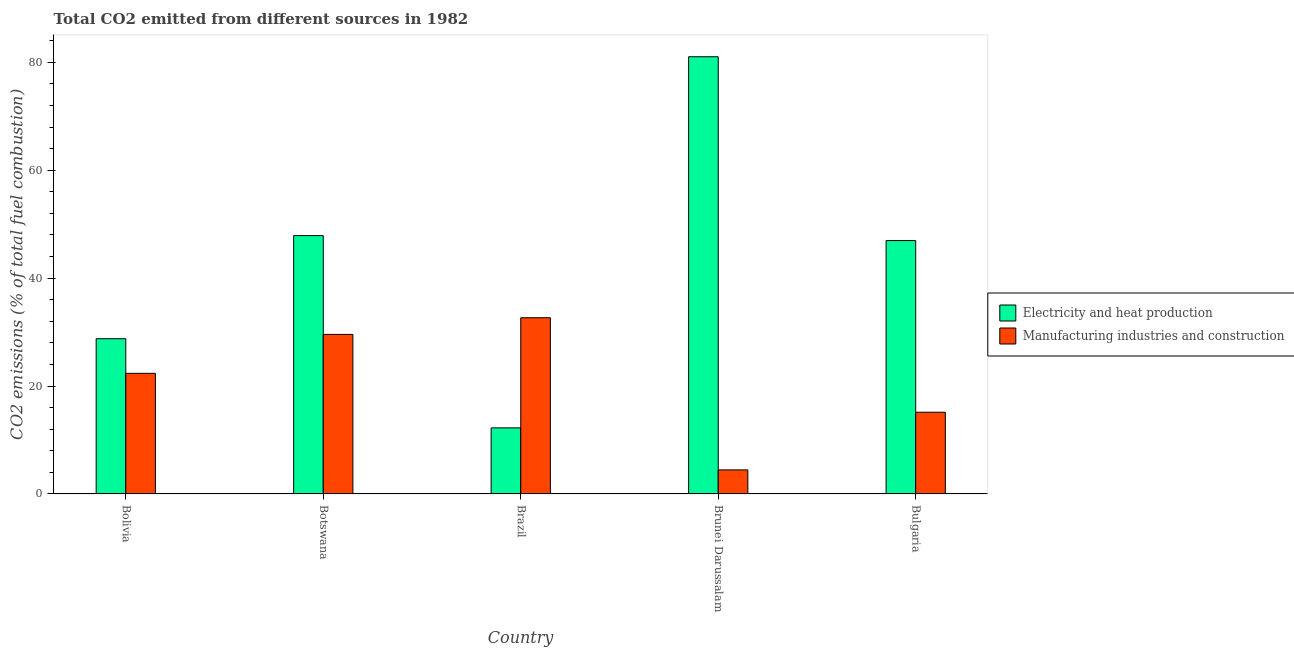How many different coloured bars are there?
Offer a very short reply. 2. How many groups of bars are there?
Your answer should be very brief. 5. Are the number of bars per tick equal to the number of legend labels?
Give a very brief answer. Yes. Are the number of bars on each tick of the X-axis equal?
Offer a terse response. Yes. How many bars are there on the 3rd tick from the left?
Offer a very short reply. 2. What is the label of the 5th group of bars from the left?
Provide a succinct answer. Bulgaria. In how many cases, is the number of bars for a given country not equal to the number of legend labels?
Keep it short and to the point. 0. What is the co2 emissions due to manufacturing industries in Bolivia?
Offer a terse response. 22.36. Across all countries, what is the maximum co2 emissions due to electricity and heat production?
Make the answer very short. 81.04. Across all countries, what is the minimum co2 emissions due to manufacturing industries?
Your response must be concise. 4.46. In which country was the co2 emissions due to electricity and heat production maximum?
Ensure brevity in your answer.  Brunei Darussalam. In which country was the co2 emissions due to manufacturing industries minimum?
Provide a short and direct response. Brunei Darussalam. What is the total co2 emissions due to electricity and heat production in the graph?
Give a very brief answer. 216.92. What is the difference between the co2 emissions due to manufacturing industries in Botswana and that in Bulgaria?
Provide a succinct answer. 14.43. What is the difference between the co2 emissions due to electricity and heat production in Brunei Darussalam and the co2 emissions due to manufacturing industries in Bulgaria?
Your response must be concise. 65.89. What is the average co2 emissions due to manufacturing industries per country?
Give a very brief answer. 20.84. What is the difference between the co2 emissions due to electricity and heat production and co2 emissions due to manufacturing industries in Bolivia?
Ensure brevity in your answer.  6.42. What is the ratio of the co2 emissions due to manufacturing industries in Botswana to that in Brunei Darussalam?
Keep it short and to the point. 6.63. Is the difference between the co2 emissions due to electricity and heat production in Bolivia and Brunei Darussalam greater than the difference between the co2 emissions due to manufacturing industries in Bolivia and Brunei Darussalam?
Your answer should be very brief. No. What is the difference between the highest and the second highest co2 emissions due to manufacturing industries?
Your answer should be compact. 3.09. What is the difference between the highest and the lowest co2 emissions due to manufacturing industries?
Offer a very short reply. 28.2. In how many countries, is the co2 emissions due to manufacturing industries greater than the average co2 emissions due to manufacturing industries taken over all countries?
Give a very brief answer. 3. Is the sum of the co2 emissions due to electricity and heat production in Botswana and Bulgaria greater than the maximum co2 emissions due to manufacturing industries across all countries?
Provide a succinct answer. Yes. What does the 1st bar from the left in Brunei Darussalam represents?
Your answer should be compact. Electricity and heat production. What does the 1st bar from the right in Bolivia represents?
Ensure brevity in your answer.  Manufacturing industries and construction. How many countries are there in the graph?
Provide a succinct answer. 5. What is the difference between two consecutive major ticks on the Y-axis?
Ensure brevity in your answer.  20. Are the values on the major ticks of Y-axis written in scientific E-notation?
Your answer should be very brief. No. How are the legend labels stacked?
Offer a terse response. Vertical. What is the title of the graph?
Keep it short and to the point. Total CO2 emitted from different sources in 1982. What is the label or title of the Y-axis?
Your response must be concise. CO2 emissions (% of total fuel combustion). What is the CO2 emissions (% of total fuel combustion) of Electricity and heat production in Bolivia?
Make the answer very short. 28.78. What is the CO2 emissions (% of total fuel combustion) of Manufacturing industries and construction in Bolivia?
Provide a short and direct response. 22.36. What is the CO2 emissions (% of total fuel combustion) of Electricity and heat production in Botswana?
Ensure brevity in your answer.  47.89. What is the CO2 emissions (% of total fuel combustion) of Manufacturing industries and construction in Botswana?
Your answer should be very brief. 29.58. What is the CO2 emissions (% of total fuel combustion) of Electricity and heat production in Brazil?
Offer a terse response. 12.25. What is the CO2 emissions (% of total fuel combustion) in Manufacturing industries and construction in Brazil?
Provide a succinct answer. 32.67. What is the CO2 emissions (% of total fuel combustion) of Electricity and heat production in Brunei Darussalam?
Your answer should be compact. 81.04. What is the CO2 emissions (% of total fuel combustion) in Manufacturing industries and construction in Brunei Darussalam?
Offer a very short reply. 4.46. What is the CO2 emissions (% of total fuel combustion) in Electricity and heat production in Bulgaria?
Keep it short and to the point. 46.97. What is the CO2 emissions (% of total fuel combustion) of Manufacturing industries and construction in Bulgaria?
Give a very brief answer. 15.15. Across all countries, what is the maximum CO2 emissions (% of total fuel combustion) of Electricity and heat production?
Give a very brief answer. 81.04. Across all countries, what is the maximum CO2 emissions (% of total fuel combustion) of Manufacturing industries and construction?
Give a very brief answer. 32.67. Across all countries, what is the minimum CO2 emissions (% of total fuel combustion) in Electricity and heat production?
Make the answer very short. 12.25. Across all countries, what is the minimum CO2 emissions (% of total fuel combustion) in Manufacturing industries and construction?
Your answer should be compact. 4.46. What is the total CO2 emissions (% of total fuel combustion) of Electricity and heat production in the graph?
Give a very brief answer. 216.92. What is the total CO2 emissions (% of total fuel combustion) of Manufacturing industries and construction in the graph?
Make the answer very short. 104.21. What is the difference between the CO2 emissions (% of total fuel combustion) of Electricity and heat production in Bolivia and that in Botswana?
Provide a succinct answer. -19.11. What is the difference between the CO2 emissions (% of total fuel combustion) of Manufacturing industries and construction in Bolivia and that in Botswana?
Provide a succinct answer. -7.22. What is the difference between the CO2 emissions (% of total fuel combustion) in Electricity and heat production in Bolivia and that in Brazil?
Offer a terse response. 16.53. What is the difference between the CO2 emissions (% of total fuel combustion) of Manufacturing industries and construction in Bolivia and that in Brazil?
Give a very brief answer. -10.31. What is the difference between the CO2 emissions (% of total fuel combustion) in Electricity and heat production in Bolivia and that in Brunei Darussalam?
Offer a very short reply. -52.26. What is the difference between the CO2 emissions (% of total fuel combustion) of Manufacturing industries and construction in Bolivia and that in Brunei Darussalam?
Offer a terse response. 17.9. What is the difference between the CO2 emissions (% of total fuel combustion) of Electricity and heat production in Bolivia and that in Bulgaria?
Provide a succinct answer. -18.19. What is the difference between the CO2 emissions (% of total fuel combustion) in Manufacturing industries and construction in Bolivia and that in Bulgaria?
Offer a terse response. 7.21. What is the difference between the CO2 emissions (% of total fuel combustion) in Electricity and heat production in Botswana and that in Brazil?
Keep it short and to the point. 35.64. What is the difference between the CO2 emissions (% of total fuel combustion) of Manufacturing industries and construction in Botswana and that in Brazil?
Your answer should be very brief. -3.09. What is the difference between the CO2 emissions (% of total fuel combustion) of Electricity and heat production in Botswana and that in Brunei Darussalam?
Keep it short and to the point. -33.15. What is the difference between the CO2 emissions (% of total fuel combustion) of Manufacturing industries and construction in Botswana and that in Brunei Darussalam?
Offer a very short reply. 25.12. What is the difference between the CO2 emissions (% of total fuel combustion) in Electricity and heat production in Botswana and that in Bulgaria?
Make the answer very short. 0.92. What is the difference between the CO2 emissions (% of total fuel combustion) of Manufacturing industries and construction in Botswana and that in Bulgaria?
Make the answer very short. 14.43. What is the difference between the CO2 emissions (% of total fuel combustion) in Electricity and heat production in Brazil and that in Brunei Darussalam?
Make the answer very short. -68.79. What is the difference between the CO2 emissions (% of total fuel combustion) in Manufacturing industries and construction in Brazil and that in Brunei Darussalam?
Your answer should be very brief. 28.2. What is the difference between the CO2 emissions (% of total fuel combustion) in Electricity and heat production in Brazil and that in Bulgaria?
Provide a short and direct response. -34.72. What is the difference between the CO2 emissions (% of total fuel combustion) in Manufacturing industries and construction in Brazil and that in Bulgaria?
Make the answer very short. 17.52. What is the difference between the CO2 emissions (% of total fuel combustion) of Electricity and heat production in Brunei Darussalam and that in Bulgaria?
Your response must be concise. 34.07. What is the difference between the CO2 emissions (% of total fuel combustion) in Manufacturing industries and construction in Brunei Darussalam and that in Bulgaria?
Give a very brief answer. -10.69. What is the difference between the CO2 emissions (% of total fuel combustion) of Electricity and heat production in Bolivia and the CO2 emissions (% of total fuel combustion) of Manufacturing industries and construction in Botswana?
Keep it short and to the point. -0.8. What is the difference between the CO2 emissions (% of total fuel combustion) in Electricity and heat production in Bolivia and the CO2 emissions (% of total fuel combustion) in Manufacturing industries and construction in Brazil?
Keep it short and to the point. -3.89. What is the difference between the CO2 emissions (% of total fuel combustion) in Electricity and heat production in Bolivia and the CO2 emissions (% of total fuel combustion) in Manufacturing industries and construction in Brunei Darussalam?
Provide a short and direct response. 24.32. What is the difference between the CO2 emissions (% of total fuel combustion) in Electricity and heat production in Bolivia and the CO2 emissions (% of total fuel combustion) in Manufacturing industries and construction in Bulgaria?
Your answer should be compact. 13.63. What is the difference between the CO2 emissions (% of total fuel combustion) in Electricity and heat production in Botswana and the CO2 emissions (% of total fuel combustion) in Manufacturing industries and construction in Brazil?
Keep it short and to the point. 15.22. What is the difference between the CO2 emissions (% of total fuel combustion) in Electricity and heat production in Botswana and the CO2 emissions (% of total fuel combustion) in Manufacturing industries and construction in Brunei Darussalam?
Your response must be concise. 43.43. What is the difference between the CO2 emissions (% of total fuel combustion) in Electricity and heat production in Botswana and the CO2 emissions (% of total fuel combustion) in Manufacturing industries and construction in Bulgaria?
Your answer should be very brief. 32.74. What is the difference between the CO2 emissions (% of total fuel combustion) in Electricity and heat production in Brazil and the CO2 emissions (% of total fuel combustion) in Manufacturing industries and construction in Brunei Darussalam?
Make the answer very short. 7.79. What is the difference between the CO2 emissions (% of total fuel combustion) in Electricity and heat production in Brazil and the CO2 emissions (% of total fuel combustion) in Manufacturing industries and construction in Bulgaria?
Your answer should be compact. -2.9. What is the difference between the CO2 emissions (% of total fuel combustion) of Electricity and heat production in Brunei Darussalam and the CO2 emissions (% of total fuel combustion) of Manufacturing industries and construction in Bulgaria?
Offer a terse response. 65.89. What is the average CO2 emissions (% of total fuel combustion) in Electricity and heat production per country?
Your answer should be compact. 43.38. What is the average CO2 emissions (% of total fuel combustion) of Manufacturing industries and construction per country?
Keep it short and to the point. 20.84. What is the difference between the CO2 emissions (% of total fuel combustion) in Electricity and heat production and CO2 emissions (% of total fuel combustion) in Manufacturing industries and construction in Bolivia?
Give a very brief answer. 6.42. What is the difference between the CO2 emissions (% of total fuel combustion) of Electricity and heat production and CO2 emissions (% of total fuel combustion) of Manufacturing industries and construction in Botswana?
Offer a terse response. 18.31. What is the difference between the CO2 emissions (% of total fuel combustion) in Electricity and heat production and CO2 emissions (% of total fuel combustion) in Manufacturing industries and construction in Brazil?
Your answer should be compact. -20.42. What is the difference between the CO2 emissions (% of total fuel combustion) of Electricity and heat production and CO2 emissions (% of total fuel combustion) of Manufacturing industries and construction in Brunei Darussalam?
Make the answer very short. 76.58. What is the difference between the CO2 emissions (% of total fuel combustion) in Electricity and heat production and CO2 emissions (% of total fuel combustion) in Manufacturing industries and construction in Bulgaria?
Provide a succinct answer. 31.82. What is the ratio of the CO2 emissions (% of total fuel combustion) of Electricity and heat production in Bolivia to that in Botswana?
Offer a very short reply. 0.6. What is the ratio of the CO2 emissions (% of total fuel combustion) in Manufacturing industries and construction in Bolivia to that in Botswana?
Your answer should be compact. 0.76. What is the ratio of the CO2 emissions (% of total fuel combustion) in Electricity and heat production in Bolivia to that in Brazil?
Your answer should be very brief. 2.35. What is the ratio of the CO2 emissions (% of total fuel combustion) in Manufacturing industries and construction in Bolivia to that in Brazil?
Give a very brief answer. 0.68. What is the ratio of the CO2 emissions (% of total fuel combustion) in Electricity and heat production in Bolivia to that in Brunei Darussalam?
Ensure brevity in your answer.  0.36. What is the ratio of the CO2 emissions (% of total fuel combustion) of Manufacturing industries and construction in Bolivia to that in Brunei Darussalam?
Your answer should be very brief. 5.01. What is the ratio of the CO2 emissions (% of total fuel combustion) of Electricity and heat production in Bolivia to that in Bulgaria?
Keep it short and to the point. 0.61. What is the ratio of the CO2 emissions (% of total fuel combustion) in Manufacturing industries and construction in Bolivia to that in Bulgaria?
Offer a very short reply. 1.48. What is the ratio of the CO2 emissions (% of total fuel combustion) of Electricity and heat production in Botswana to that in Brazil?
Your answer should be compact. 3.91. What is the ratio of the CO2 emissions (% of total fuel combustion) in Manufacturing industries and construction in Botswana to that in Brazil?
Your response must be concise. 0.91. What is the ratio of the CO2 emissions (% of total fuel combustion) in Electricity and heat production in Botswana to that in Brunei Darussalam?
Make the answer very short. 0.59. What is the ratio of the CO2 emissions (% of total fuel combustion) in Manufacturing industries and construction in Botswana to that in Brunei Darussalam?
Your response must be concise. 6.63. What is the ratio of the CO2 emissions (% of total fuel combustion) of Electricity and heat production in Botswana to that in Bulgaria?
Ensure brevity in your answer.  1.02. What is the ratio of the CO2 emissions (% of total fuel combustion) in Manufacturing industries and construction in Botswana to that in Bulgaria?
Offer a terse response. 1.95. What is the ratio of the CO2 emissions (% of total fuel combustion) in Electricity and heat production in Brazil to that in Brunei Darussalam?
Make the answer very short. 0.15. What is the ratio of the CO2 emissions (% of total fuel combustion) of Manufacturing industries and construction in Brazil to that in Brunei Darussalam?
Your response must be concise. 7.32. What is the ratio of the CO2 emissions (% of total fuel combustion) in Electricity and heat production in Brazil to that in Bulgaria?
Your answer should be compact. 0.26. What is the ratio of the CO2 emissions (% of total fuel combustion) of Manufacturing industries and construction in Brazil to that in Bulgaria?
Provide a short and direct response. 2.16. What is the ratio of the CO2 emissions (% of total fuel combustion) of Electricity and heat production in Brunei Darussalam to that in Bulgaria?
Provide a short and direct response. 1.73. What is the ratio of the CO2 emissions (% of total fuel combustion) of Manufacturing industries and construction in Brunei Darussalam to that in Bulgaria?
Your response must be concise. 0.29. What is the difference between the highest and the second highest CO2 emissions (% of total fuel combustion) in Electricity and heat production?
Offer a terse response. 33.15. What is the difference between the highest and the second highest CO2 emissions (% of total fuel combustion) in Manufacturing industries and construction?
Ensure brevity in your answer.  3.09. What is the difference between the highest and the lowest CO2 emissions (% of total fuel combustion) of Electricity and heat production?
Offer a very short reply. 68.79. What is the difference between the highest and the lowest CO2 emissions (% of total fuel combustion) of Manufacturing industries and construction?
Offer a terse response. 28.2. 